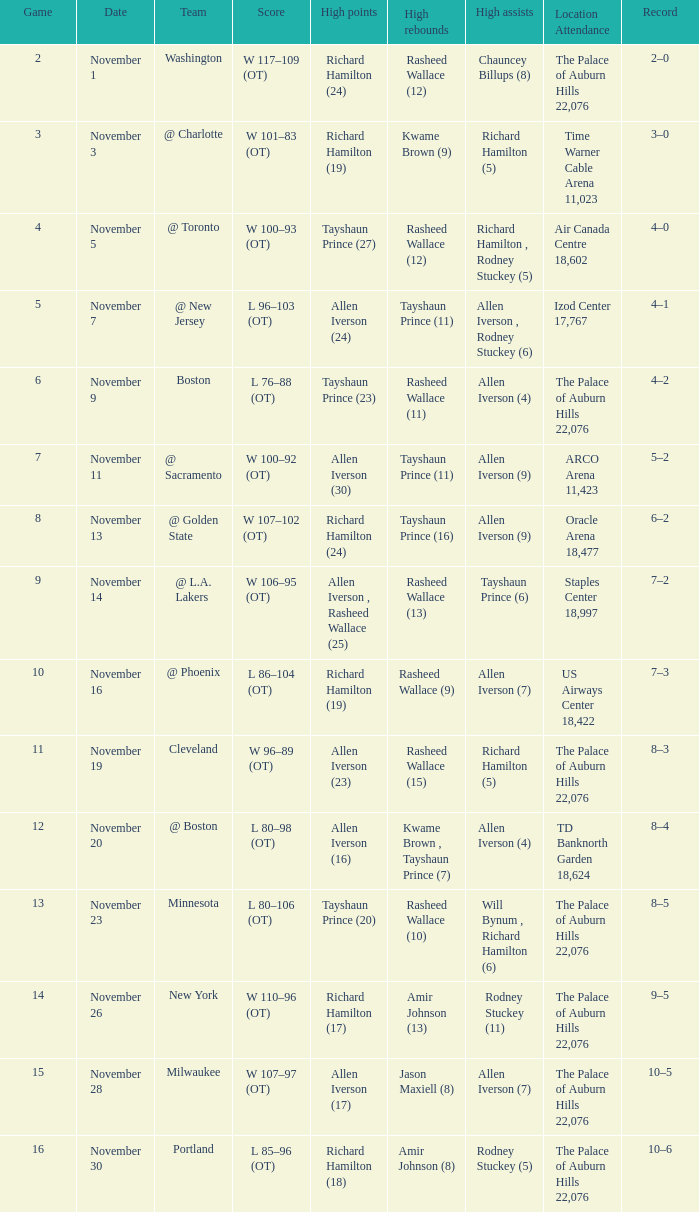What is Location Attendance, when High Points is "Allen Iverson (23)"? The Palace of Auburn Hills 22,076. 